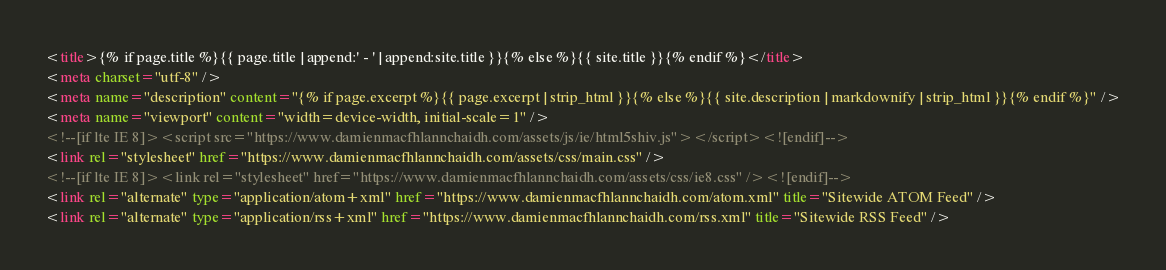Convert code to text. <code><loc_0><loc_0><loc_500><loc_500><_HTML_><title>{% if page.title %}{{ page.title | append:' - ' | append:site.title }}{% else %}{{ site.title }}{% endif %}</title>
<meta charset="utf-8" />
<meta name="description" content="{% if page.excerpt %}{{ page.excerpt | strip_html }}{% else %}{{ site.description | markdownify | strip_html }}{% endif %}" />
<meta name="viewport" content="width=device-width, initial-scale=1" />
<!--[if lte IE 8]><script src="https://www.damienmacfhlannchaidh.com/assets/js/ie/html5shiv.js"></script><![endif]-->
<link rel="stylesheet" href="https://www.damienmacfhlannchaidh.com/assets/css/main.css" />
<!--[if lte IE 8]><link rel="stylesheet" href="https://www.damienmacfhlannchaidh.com/assets/css/ie8.css" /><![endif]-->
<link rel="alternate" type="application/atom+xml" href="https://www.damienmacfhlannchaidh.com/atom.xml" title="Sitewide ATOM Feed" />
<link rel="alternate" type="application/rss+xml" href="https://www.damienmacfhlannchaidh.com/rss.xml" title="Sitewide RSS Feed" /></code> 